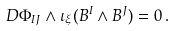Convert formula to latex. <formula><loc_0><loc_0><loc_500><loc_500>D \Phi _ { I J } \wedge \iota _ { \xi } ( B ^ { I } \wedge B ^ { J } ) = 0 \, .</formula> 